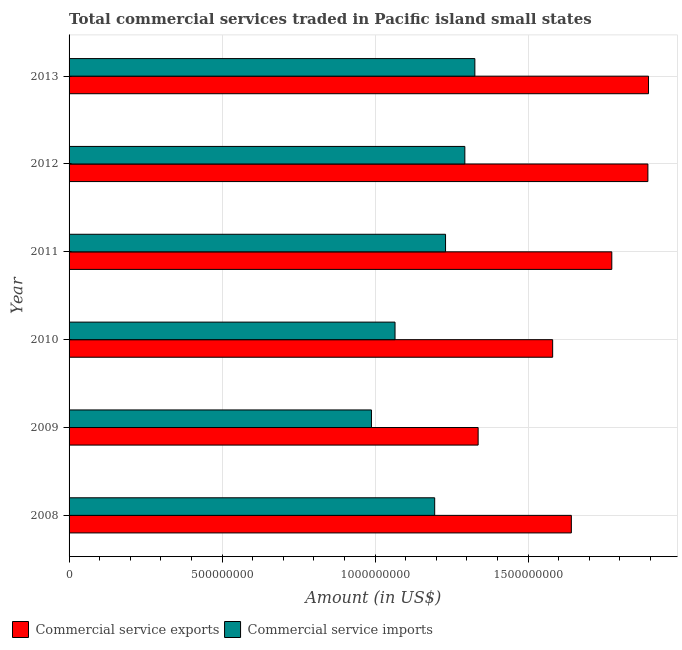How many groups of bars are there?
Provide a short and direct response. 6. Are the number of bars per tick equal to the number of legend labels?
Ensure brevity in your answer.  Yes. How many bars are there on the 6th tick from the top?
Provide a short and direct response. 2. How many bars are there on the 6th tick from the bottom?
Ensure brevity in your answer.  2. In how many cases, is the number of bars for a given year not equal to the number of legend labels?
Offer a very short reply. 0. What is the amount of commercial service exports in 2012?
Keep it short and to the point. 1.89e+09. Across all years, what is the maximum amount of commercial service exports?
Keep it short and to the point. 1.89e+09. Across all years, what is the minimum amount of commercial service imports?
Give a very brief answer. 9.88e+08. In which year was the amount of commercial service exports minimum?
Your answer should be very brief. 2009. What is the total amount of commercial service exports in the graph?
Keep it short and to the point. 1.01e+1. What is the difference between the amount of commercial service imports in 2008 and that in 2009?
Your answer should be very brief. 2.07e+08. What is the difference between the amount of commercial service imports in 2010 and the amount of commercial service exports in 2012?
Your response must be concise. -8.26e+08. What is the average amount of commercial service exports per year?
Your response must be concise. 1.69e+09. In the year 2013, what is the difference between the amount of commercial service exports and amount of commercial service imports?
Offer a terse response. 5.67e+08. In how many years, is the amount of commercial service imports greater than 200000000 US$?
Make the answer very short. 6. What is the ratio of the amount of commercial service imports in 2009 to that in 2013?
Give a very brief answer. 0.74. What is the difference between the highest and the second highest amount of commercial service imports?
Your answer should be very brief. 3.27e+07. What is the difference between the highest and the lowest amount of commercial service exports?
Offer a very short reply. 5.57e+08. What does the 2nd bar from the top in 2013 represents?
Your answer should be very brief. Commercial service exports. What does the 2nd bar from the bottom in 2011 represents?
Provide a short and direct response. Commercial service imports. Are the values on the major ticks of X-axis written in scientific E-notation?
Your response must be concise. No. Does the graph contain any zero values?
Provide a succinct answer. No. Where does the legend appear in the graph?
Offer a terse response. Bottom left. How are the legend labels stacked?
Ensure brevity in your answer.  Horizontal. What is the title of the graph?
Ensure brevity in your answer.  Total commercial services traded in Pacific island small states. What is the label or title of the Y-axis?
Your response must be concise. Year. What is the Amount (in US$) in Commercial service exports in 2008?
Provide a succinct answer. 1.64e+09. What is the Amount (in US$) in Commercial service imports in 2008?
Keep it short and to the point. 1.19e+09. What is the Amount (in US$) in Commercial service exports in 2009?
Your response must be concise. 1.34e+09. What is the Amount (in US$) of Commercial service imports in 2009?
Make the answer very short. 9.88e+08. What is the Amount (in US$) of Commercial service exports in 2010?
Make the answer very short. 1.58e+09. What is the Amount (in US$) of Commercial service imports in 2010?
Provide a succinct answer. 1.07e+09. What is the Amount (in US$) of Commercial service exports in 2011?
Offer a terse response. 1.77e+09. What is the Amount (in US$) in Commercial service imports in 2011?
Keep it short and to the point. 1.23e+09. What is the Amount (in US$) of Commercial service exports in 2012?
Offer a very short reply. 1.89e+09. What is the Amount (in US$) of Commercial service imports in 2012?
Keep it short and to the point. 1.29e+09. What is the Amount (in US$) in Commercial service exports in 2013?
Offer a very short reply. 1.89e+09. What is the Amount (in US$) of Commercial service imports in 2013?
Provide a short and direct response. 1.33e+09. Across all years, what is the maximum Amount (in US$) of Commercial service exports?
Your answer should be compact. 1.89e+09. Across all years, what is the maximum Amount (in US$) in Commercial service imports?
Provide a short and direct response. 1.33e+09. Across all years, what is the minimum Amount (in US$) in Commercial service exports?
Provide a succinct answer. 1.34e+09. Across all years, what is the minimum Amount (in US$) of Commercial service imports?
Offer a terse response. 9.88e+08. What is the total Amount (in US$) of Commercial service exports in the graph?
Give a very brief answer. 1.01e+1. What is the total Amount (in US$) of Commercial service imports in the graph?
Offer a terse response. 7.10e+09. What is the difference between the Amount (in US$) in Commercial service exports in 2008 and that in 2009?
Offer a terse response. 3.05e+08. What is the difference between the Amount (in US$) in Commercial service imports in 2008 and that in 2009?
Your answer should be compact. 2.07e+08. What is the difference between the Amount (in US$) in Commercial service exports in 2008 and that in 2010?
Your response must be concise. 6.11e+07. What is the difference between the Amount (in US$) in Commercial service imports in 2008 and that in 2010?
Ensure brevity in your answer.  1.30e+08. What is the difference between the Amount (in US$) of Commercial service exports in 2008 and that in 2011?
Provide a succinct answer. -1.32e+08. What is the difference between the Amount (in US$) in Commercial service imports in 2008 and that in 2011?
Provide a succinct answer. -3.54e+07. What is the difference between the Amount (in US$) in Commercial service exports in 2008 and that in 2012?
Your response must be concise. -2.50e+08. What is the difference between the Amount (in US$) in Commercial service imports in 2008 and that in 2012?
Your answer should be compact. -9.85e+07. What is the difference between the Amount (in US$) of Commercial service exports in 2008 and that in 2013?
Provide a short and direct response. -2.52e+08. What is the difference between the Amount (in US$) in Commercial service imports in 2008 and that in 2013?
Keep it short and to the point. -1.31e+08. What is the difference between the Amount (in US$) in Commercial service exports in 2009 and that in 2010?
Ensure brevity in your answer.  -2.43e+08. What is the difference between the Amount (in US$) in Commercial service imports in 2009 and that in 2010?
Give a very brief answer. -7.70e+07. What is the difference between the Amount (in US$) of Commercial service exports in 2009 and that in 2011?
Your response must be concise. -4.37e+08. What is the difference between the Amount (in US$) of Commercial service imports in 2009 and that in 2011?
Offer a terse response. -2.42e+08. What is the difference between the Amount (in US$) in Commercial service exports in 2009 and that in 2012?
Your answer should be compact. -5.55e+08. What is the difference between the Amount (in US$) in Commercial service imports in 2009 and that in 2012?
Provide a short and direct response. -3.05e+08. What is the difference between the Amount (in US$) of Commercial service exports in 2009 and that in 2013?
Your answer should be very brief. -5.57e+08. What is the difference between the Amount (in US$) of Commercial service imports in 2009 and that in 2013?
Your answer should be compact. -3.38e+08. What is the difference between the Amount (in US$) in Commercial service exports in 2010 and that in 2011?
Offer a very short reply. -1.93e+08. What is the difference between the Amount (in US$) in Commercial service imports in 2010 and that in 2011?
Provide a short and direct response. -1.65e+08. What is the difference between the Amount (in US$) of Commercial service exports in 2010 and that in 2012?
Your response must be concise. -3.11e+08. What is the difference between the Amount (in US$) of Commercial service imports in 2010 and that in 2012?
Offer a terse response. -2.28e+08. What is the difference between the Amount (in US$) in Commercial service exports in 2010 and that in 2013?
Keep it short and to the point. -3.13e+08. What is the difference between the Amount (in US$) of Commercial service imports in 2010 and that in 2013?
Provide a succinct answer. -2.61e+08. What is the difference between the Amount (in US$) of Commercial service exports in 2011 and that in 2012?
Ensure brevity in your answer.  -1.18e+08. What is the difference between the Amount (in US$) in Commercial service imports in 2011 and that in 2012?
Your response must be concise. -6.30e+07. What is the difference between the Amount (in US$) of Commercial service exports in 2011 and that in 2013?
Make the answer very short. -1.20e+08. What is the difference between the Amount (in US$) in Commercial service imports in 2011 and that in 2013?
Give a very brief answer. -9.58e+07. What is the difference between the Amount (in US$) of Commercial service exports in 2012 and that in 2013?
Make the answer very short. -2.06e+06. What is the difference between the Amount (in US$) of Commercial service imports in 2012 and that in 2013?
Your answer should be compact. -3.27e+07. What is the difference between the Amount (in US$) in Commercial service exports in 2008 and the Amount (in US$) in Commercial service imports in 2009?
Provide a succinct answer. 6.53e+08. What is the difference between the Amount (in US$) of Commercial service exports in 2008 and the Amount (in US$) of Commercial service imports in 2010?
Provide a short and direct response. 5.76e+08. What is the difference between the Amount (in US$) in Commercial service exports in 2008 and the Amount (in US$) in Commercial service imports in 2011?
Provide a succinct answer. 4.11e+08. What is the difference between the Amount (in US$) of Commercial service exports in 2008 and the Amount (in US$) of Commercial service imports in 2012?
Your response must be concise. 3.48e+08. What is the difference between the Amount (in US$) in Commercial service exports in 2008 and the Amount (in US$) in Commercial service imports in 2013?
Ensure brevity in your answer.  3.15e+08. What is the difference between the Amount (in US$) in Commercial service exports in 2009 and the Amount (in US$) in Commercial service imports in 2010?
Ensure brevity in your answer.  2.72e+08. What is the difference between the Amount (in US$) in Commercial service exports in 2009 and the Amount (in US$) in Commercial service imports in 2011?
Offer a terse response. 1.07e+08. What is the difference between the Amount (in US$) in Commercial service exports in 2009 and the Amount (in US$) in Commercial service imports in 2012?
Offer a very short reply. 4.35e+07. What is the difference between the Amount (in US$) of Commercial service exports in 2009 and the Amount (in US$) of Commercial service imports in 2013?
Make the answer very short. 1.07e+07. What is the difference between the Amount (in US$) in Commercial service exports in 2010 and the Amount (in US$) in Commercial service imports in 2011?
Offer a terse response. 3.50e+08. What is the difference between the Amount (in US$) in Commercial service exports in 2010 and the Amount (in US$) in Commercial service imports in 2012?
Offer a very short reply. 2.87e+08. What is the difference between the Amount (in US$) of Commercial service exports in 2010 and the Amount (in US$) of Commercial service imports in 2013?
Give a very brief answer. 2.54e+08. What is the difference between the Amount (in US$) of Commercial service exports in 2011 and the Amount (in US$) of Commercial service imports in 2012?
Provide a succinct answer. 4.80e+08. What is the difference between the Amount (in US$) of Commercial service exports in 2011 and the Amount (in US$) of Commercial service imports in 2013?
Provide a succinct answer. 4.47e+08. What is the difference between the Amount (in US$) in Commercial service exports in 2012 and the Amount (in US$) in Commercial service imports in 2013?
Provide a succinct answer. 5.65e+08. What is the average Amount (in US$) in Commercial service exports per year?
Offer a terse response. 1.69e+09. What is the average Amount (in US$) in Commercial service imports per year?
Your answer should be very brief. 1.18e+09. In the year 2008, what is the difference between the Amount (in US$) in Commercial service exports and Amount (in US$) in Commercial service imports?
Offer a terse response. 4.47e+08. In the year 2009, what is the difference between the Amount (in US$) in Commercial service exports and Amount (in US$) in Commercial service imports?
Offer a terse response. 3.49e+08. In the year 2010, what is the difference between the Amount (in US$) of Commercial service exports and Amount (in US$) of Commercial service imports?
Your answer should be compact. 5.15e+08. In the year 2011, what is the difference between the Amount (in US$) in Commercial service exports and Amount (in US$) in Commercial service imports?
Provide a short and direct response. 5.43e+08. In the year 2012, what is the difference between the Amount (in US$) of Commercial service exports and Amount (in US$) of Commercial service imports?
Offer a terse response. 5.98e+08. In the year 2013, what is the difference between the Amount (in US$) in Commercial service exports and Amount (in US$) in Commercial service imports?
Your answer should be very brief. 5.67e+08. What is the ratio of the Amount (in US$) of Commercial service exports in 2008 to that in 2009?
Your response must be concise. 1.23. What is the ratio of the Amount (in US$) of Commercial service imports in 2008 to that in 2009?
Your answer should be compact. 1.21. What is the ratio of the Amount (in US$) in Commercial service exports in 2008 to that in 2010?
Make the answer very short. 1.04. What is the ratio of the Amount (in US$) of Commercial service imports in 2008 to that in 2010?
Offer a very short reply. 1.12. What is the ratio of the Amount (in US$) in Commercial service exports in 2008 to that in 2011?
Give a very brief answer. 0.93. What is the ratio of the Amount (in US$) of Commercial service imports in 2008 to that in 2011?
Keep it short and to the point. 0.97. What is the ratio of the Amount (in US$) of Commercial service exports in 2008 to that in 2012?
Provide a short and direct response. 0.87. What is the ratio of the Amount (in US$) in Commercial service imports in 2008 to that in 2012?
Provide a short and direct response. 0.92. What is the ratio of the Amount (in US$) of Commercial service exports in 2008 to that in 2013?
Your response must be concise. 0.87. What is the ratio of the Amount (in US$) of Commercial service imports in 2008 to that in 2013?
Your answer should be compact. 0.9. What is the ratio of the Amount (in US$) in Commercial service exports in 2009 to that in 2010?
Offer a very short reply. 0.85. What is the ratio of the Amount (in US$) of Commercial service imports in 2009 to that in 2010?
Offer a terse response. 0.93. What is the ratio of the Amount (in US$) in Commercial service exports in 2009 to that in 2011?
Your answer should be very brief. 0.75. What is the ratio of the Amount (in US$) of Commercial service imports in 2009 to that in 2011?
Your answer should be compact. 0.8. What is the ratio of the Amount (in US$) of Commercial service exports in 2009 to that in 2012?
Keep it short and to the point. 0.71. What is the ratio of the Amount (in US$) in Commercial service imports in 2009 to that in 2012?
Offer a terse response. 0.76. What is the ratio of the Amount (in US$) in Commercial service exports in 2009 to that in 2013?
Your answer should be very brief. 0.71. What is the ratio of the Amount (in US$) in Commercial service imports in 2009 to that in 2013?
Offer a very short reply. 0.75. What is the ratio of the Amount (in US$) in Commercial service exports in 2010 to that in 2011?
Give a very brief answer. 0.89. What is the ratio of the Amount (in US$) of Commercial service imports in 2010 to that in 2011?
Your answer should be compact. 0.87. What is the ratio of the Amount (in US$) in Commercial service exports in 2010 to that in 2012?
Your answer should be compact. 0.84. What is the ratio of the Amount (in US$) in Commercial service imports in 2010 to that in 2012?
Offer a terse response. 0.82. What is the ratio of the Amount (in US$) in Commercial service exports in 2010 to that in 2013?
Make the answer very short. 0.83. What is the ratio of the Amount (in US$) in Commercial service imports in 2010 to that in 2013?
Give a very brief answer. 0.8. What is the ratio of the Amount (in US$) of Commercial service exports in 2011 to that in 2012?
Provide a short and direct response. 0.94. What is the ratio of the Amount (in US$) in Commercial service imports in 2011 to that in 2012?
Make the answer very short. 0.95. What is the ratio of the Amount (in US$) of Commercial service exports in 2011 to that in 2013?
Offer a very short reply. 0.94. What is the ratio of the Amount (in US$) of Commercial service imports in 2011 to that in 2013?
Your answer should be very brief. 0.93. What is the ratio of the Amount (in US$) in Commercial service imports in 2012 to that in 2013?
Your answer should be very brief. 0.98. What is the difference between the highest and the second highest Amount (in US$) in Commercial service exports?
Provide a succinct answer. 2.06e+06. What is the difference between the highest and the second highest Amount (in US$) in Commercial service imports?
Your response must be concise. 3.27e+07. What is the difference between the highest and the lowest Amount (in US$) of Commercial service exports?
Ensure brevity in your answer.  5.57e+08. What is the difference between the highest and the lowest Amount (in US$) in Commercial service imports?
Offer a very short reply. 3.38e+08. 